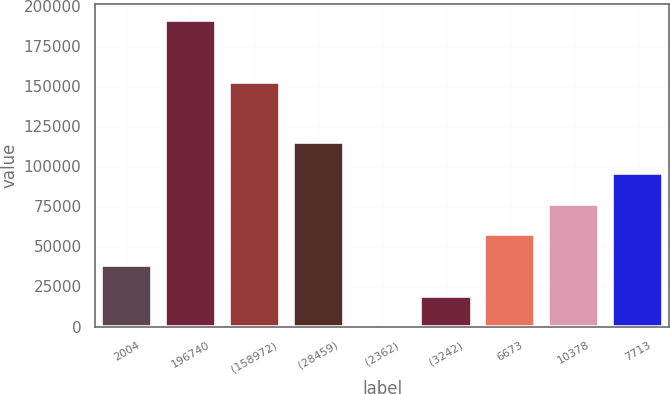<chart> <loc_0><loc_0><loc_500><loc_500><bar_chart><fcel>2004<fcel>196740<fcel>(158972)<fcel>(28459)<fcel>(2362)<fcel>(3242)<fcel>6673<fcel>10378<fcel>7713<nl><fcel>38387.4<fcel>191125<fcel>152445<fcel>114756<fcel>203<fcel>19295.2<fcel>57479.6<fcel>76571.8<fcel>95664<nl></chart> 